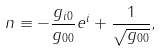<formula> <loc_0><loc_0><loc_500><loc_500>n \equiv - \frac { g _ { i 0 } } { g _ { 0 0 } } e ^ { i } + \frac { 1 } { \sqrt { g _ { 0 0 } } } ,</formula> 